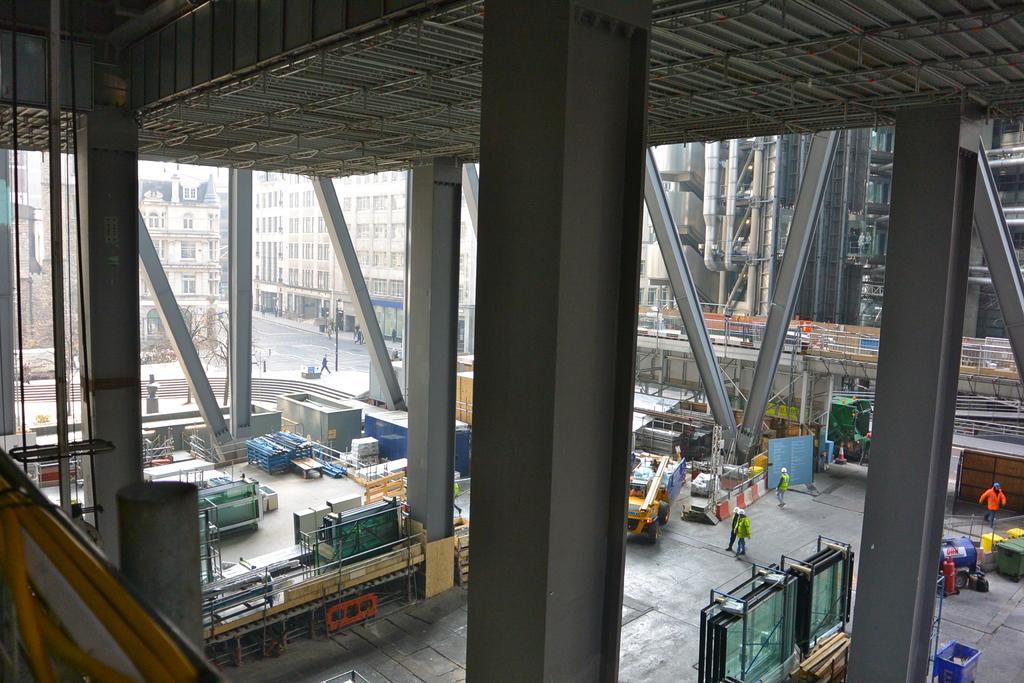How would you summarize this image in a sentence or two? In this image I can see few buildings, windows, trees, poles, colorful containers, vehicle, dustbins, wooden-logs, board, traffic cone, few people and few object around. 